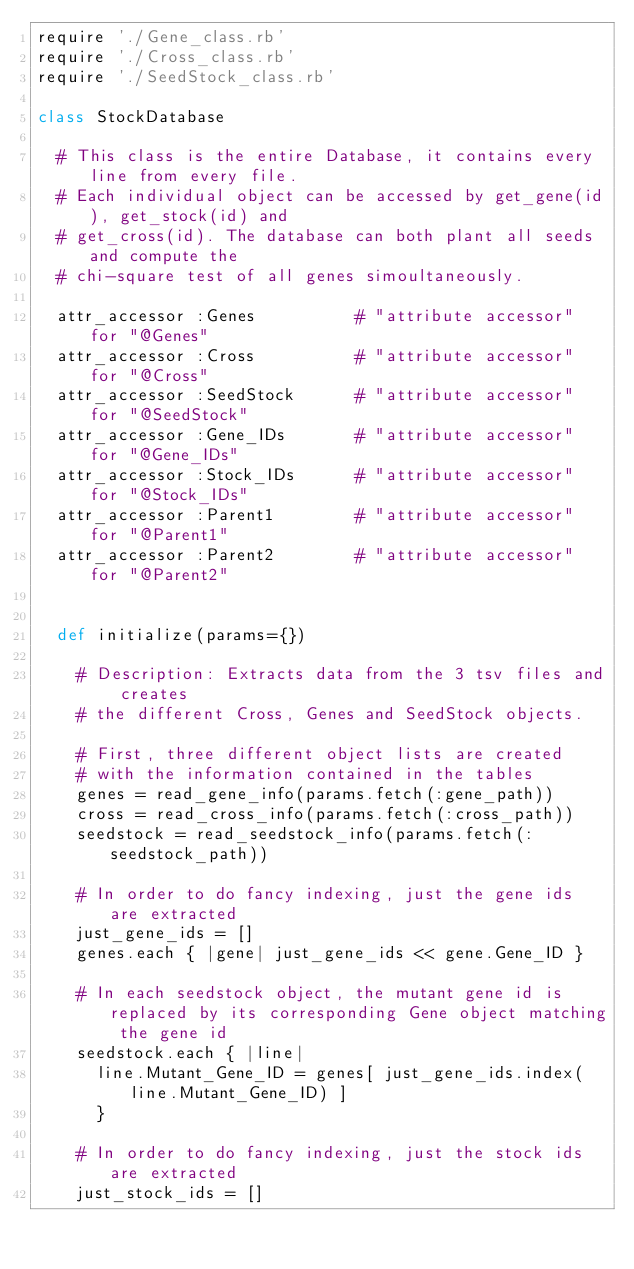Convert code to text. <code><loc_0><loc_0><loc_500><loc_500><_Ruby_>require './Gene_class.rb'
require './Cross_class.rb'
require './SeedStock_class.rb'

class StockDatabase
  
  # This class is the entire Database, it contains every line from every file.
  # Each individual object can be accessed by get_gene(id), get_stock(id) and
  # get_cross(id). The database can both plant all seeds and compute the
  # chi-square test of all genes simoultaneously. 
  
  attr_accessor :Genes          # "attribute accessor" for "@Genes"
  attr_accessor :Cross          # "attribute accessor" for "@Cross"
  attr_accessor :SeedStock      # "attribute accessor" for "@SeedStock"
  attr_accessor :Gene_IDs       # "attribute accessor" for "@Gene_IDs"
  attr_accessor :Stock_IDs      # "attribute accessor" for "@Stock_IDs"
  attr_accessor :Parent1        # "attribute accessor" for "@Parent1"
  attr_accessor :Parent2        # "attribute accessor" for "@Parent2"

  
  def initialize(params={})
    
    # Description: Extracts data from the 3 tsv files and creates
    # the different Cross, Genes and SeedStock objects. 
    
    # First, three different object lists are created
    # with the information contained in the tables
    genes = read_gene_info(params.fetch(:gene_path))
    cross = read_cross_info(params.fetch(:cross_path))
    seedstock = read_seedstock_info(params.fetch(:seedstock_path))
    
    # In order to do fancy indexing, just the gene ids are extracted
    just_gene_ids = []
    genes.each { |gene| just_gene_ids << gene.Gene_ID }

    # In each seedstock object, the mutant gene id is replaced by its corresponding Gene object matching the gene id
    seedstock.each { |line|
      line.Mutant_Gene_ID = genes[ just_gene_ids.index(line.Mutant_Gene_ID) ]
      }
    
    # In order to do fancy indexing, just the stock ids are extracted   
    just_stock_ids = []</code> 